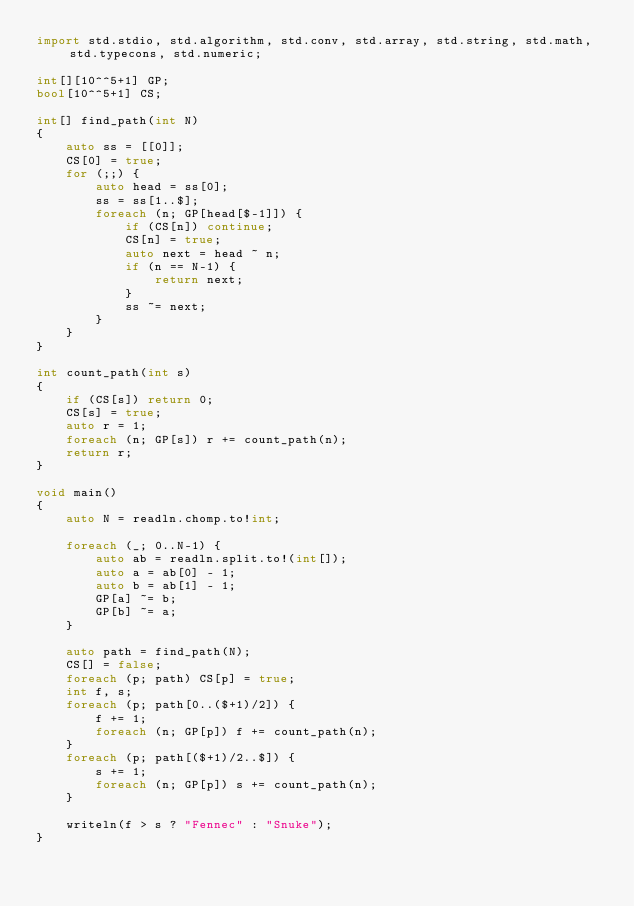Convert code to text. <code><loc_0><loc_0><loc_500><loc_500><_D_>import std.stdio, std.algorithm, std.conv, std.array, std.string, std.math, std.typecons, std.numeric;

int[][10^^5+1] GP;
bool[10^^5+1] CS;

int[] find_path(int N)
{
    auto ss = [[0]];
    CS[0] = true;
    for (;;) {
        auto head = ss[0];
        ss = ss[1..$];
        foreach (n; GP[head[$-1]]) {
            if (CS[n]) continue;
            CS[n] = true;
            auto next = head ~ n;
            if (n == N-1) {
                return next;
            }
            ss ~= next;
        }
    }
}

int count_path(int s)
{
    if (CS[s]) return 0;
    CS[s] = true;
    auto r = 1;
    foreach (n; GP[s]) r += count_path(n);
    return r;
}

void main()
{
    auto N = readln.chomp.to!int;

    foreach (_; 0..N-1) {
        auto ab = readln.split.to!(int[]);
        auto a = ab[0] - 1;
        auto b = ab[1] - 1;
        GP[a] ~= b;
        GP[b] ~= a;
    }

    auto path = find_path(N);
    CS[] = false;
    foreach (p; path) CS[p] = true;
    int f, s;
    foreach (p; path[0..($+1)/2]) {
        f += 1;
        foreach (n; GP[p]) f += count_path(n);
    }
    foreach (p; path[($+1)/2..$]) {
        s += 1;
        foreach (n; GP[p]) s += count_path(n);
    }

    writeln(f > s ? "Fennec" : "Snuke");
}</code> 